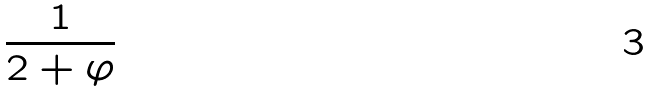Convert formula to latex. <formula><loc_0><loc_0><loc_500><loc_500>\frac { 1 } { 2 + \varphi }</formula> 